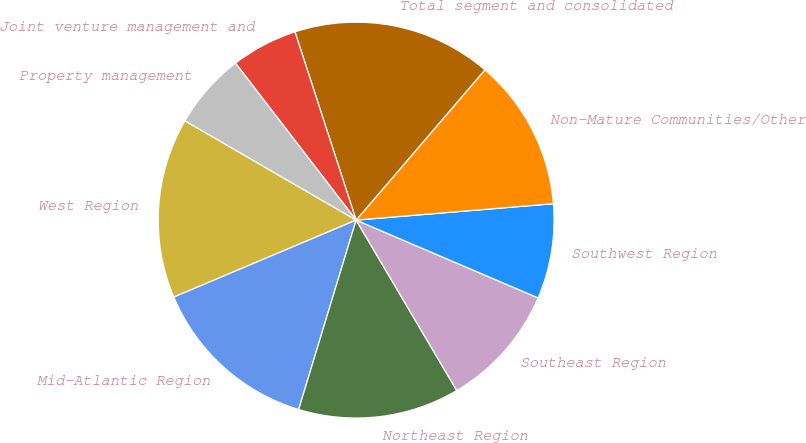<chart> <loc_0><loc_0><loc_500><loc_500><pie_chart><fcel>West Region<fcel>Mid-Atlantic Region<fcel>Northeast Region<fcel>Southeast Region<fcel>Southwest Region<fcel>Non-Mature Communities/Other<fcel>Total segment and consolidated<fcel>Joint venture management and<fcel>Property management<nl><fcel>14.73%<fcel>13.95%<fcel>13.18%<fcel>10.08%<fcel>7.75%<fcel>12.4%<fcel>16.28%<fcel>5.43%<fcel>6.2%<nl></chart> 